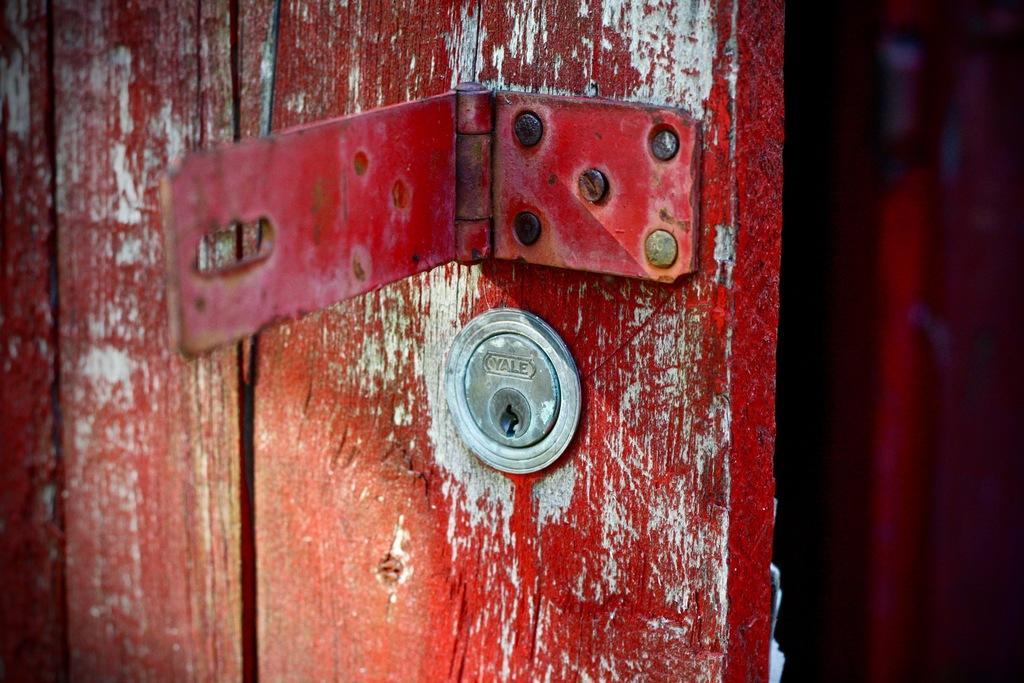How would you summarize this image in a sentence or two? In the image there is a wooden door with red and white painting. On the door there are locks and also there are screws. 